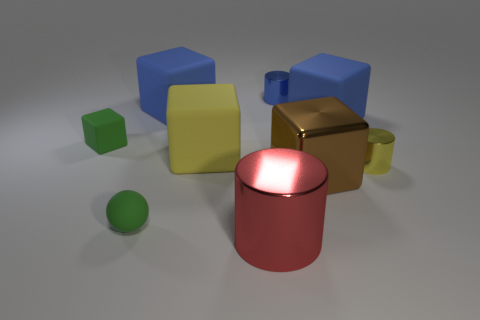There is a blue cylinder that is the same size as the green matte ball; what is its material?
Make the answer very short. Metal. How many brown objects are on the right side of the yellow shiny cylinder?
Your answer should be very brief. 0. There is a small metal object that is behind the tiny block; is it the same shape as the small yellow thing?
Make the answer very short. Yes. Is there a large green shiny object that has the same shape as the tiny yellow thing?
Your answer should be very brief. No. There is a small sphere that is the same color as the tiny rubber block; what is it made of?
Provide a succinct answer. Rubber. The tiny yellow metal object that is behind the metallic object in front of the big brown metallic cube is what shape?
Keep it short and to the point. Cylinder. What number of big yellow things are the same material as the sphere?
Ensure brevity in your answer.  1. There is another large object that is the same material as the large red thing; what color is it?
Offer a very short reply. Brown. What size is the shiny cylinder behind the tiny cylinder that is in front of the small green thing behind the big yellow rubber object?
Your answer should be compact. Small. Are there fewer big blocks than tiny shiny things?
Provide a short and direct response. No. 